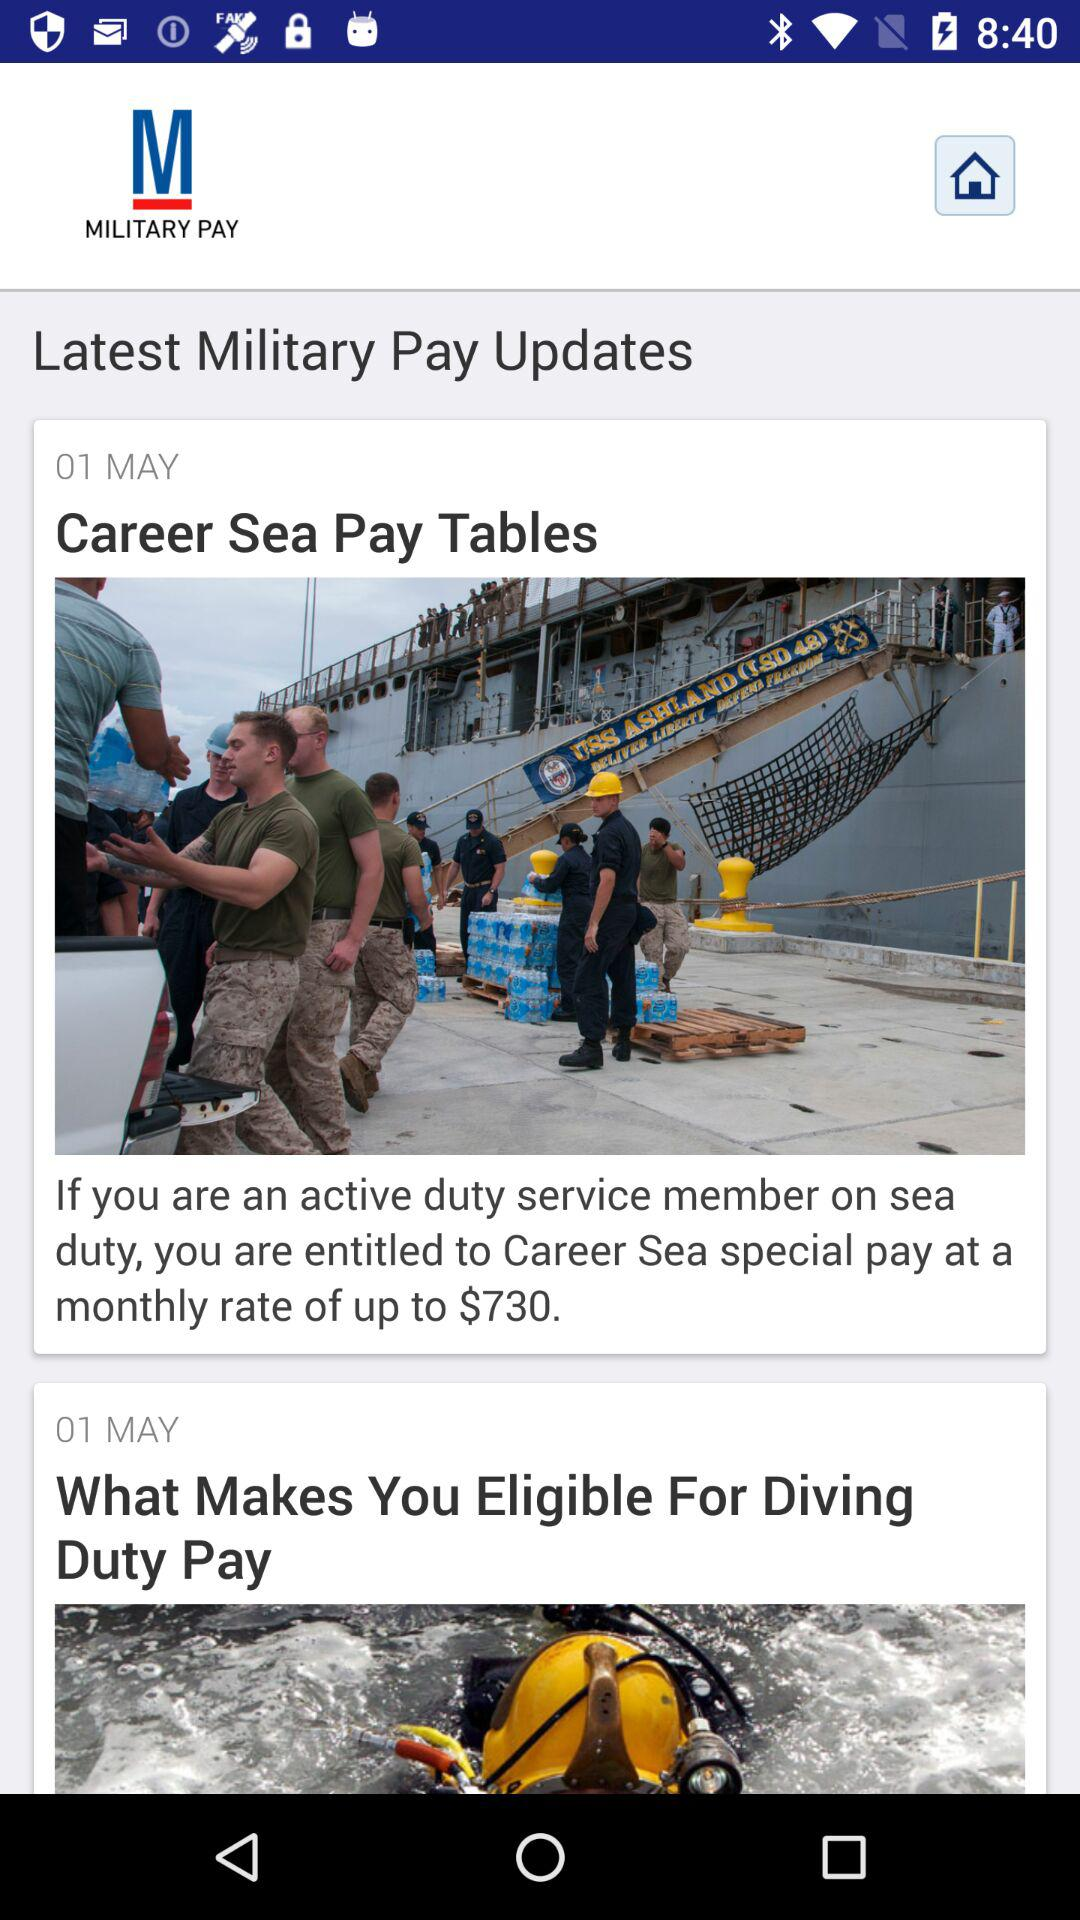What date is given? The given date is May 1. 